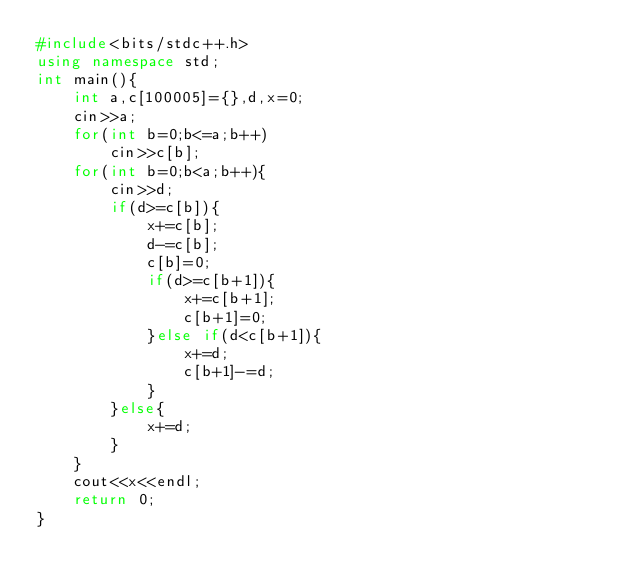<code> <loc_0><loc_0><loc_500><loc_500><_C++_>#include<bits/stdc++.h>
using namespace std;
int main(){
    int a,c[100005]={},d,x=0;
    cin>>a;
    for(int b=0;b<=a;b++)
        cin>>c[b];
    for(int b=0;b<a;b++){
        cin>>d;
        if(d>=c[b]){
            x+=c[b];
            d-=c[b];
            c[b]=0;
            if(d>=c[b+1]){
                x+=c[b+1];
                c[b+1]=0;
            }else if(d<c[b+1]){
                x+=d;
                c[b+1]-=d;
            }
        }else{
            x+=d;
        }
    }
    cout<<x<<endl;
    return 0;
}
</code> 